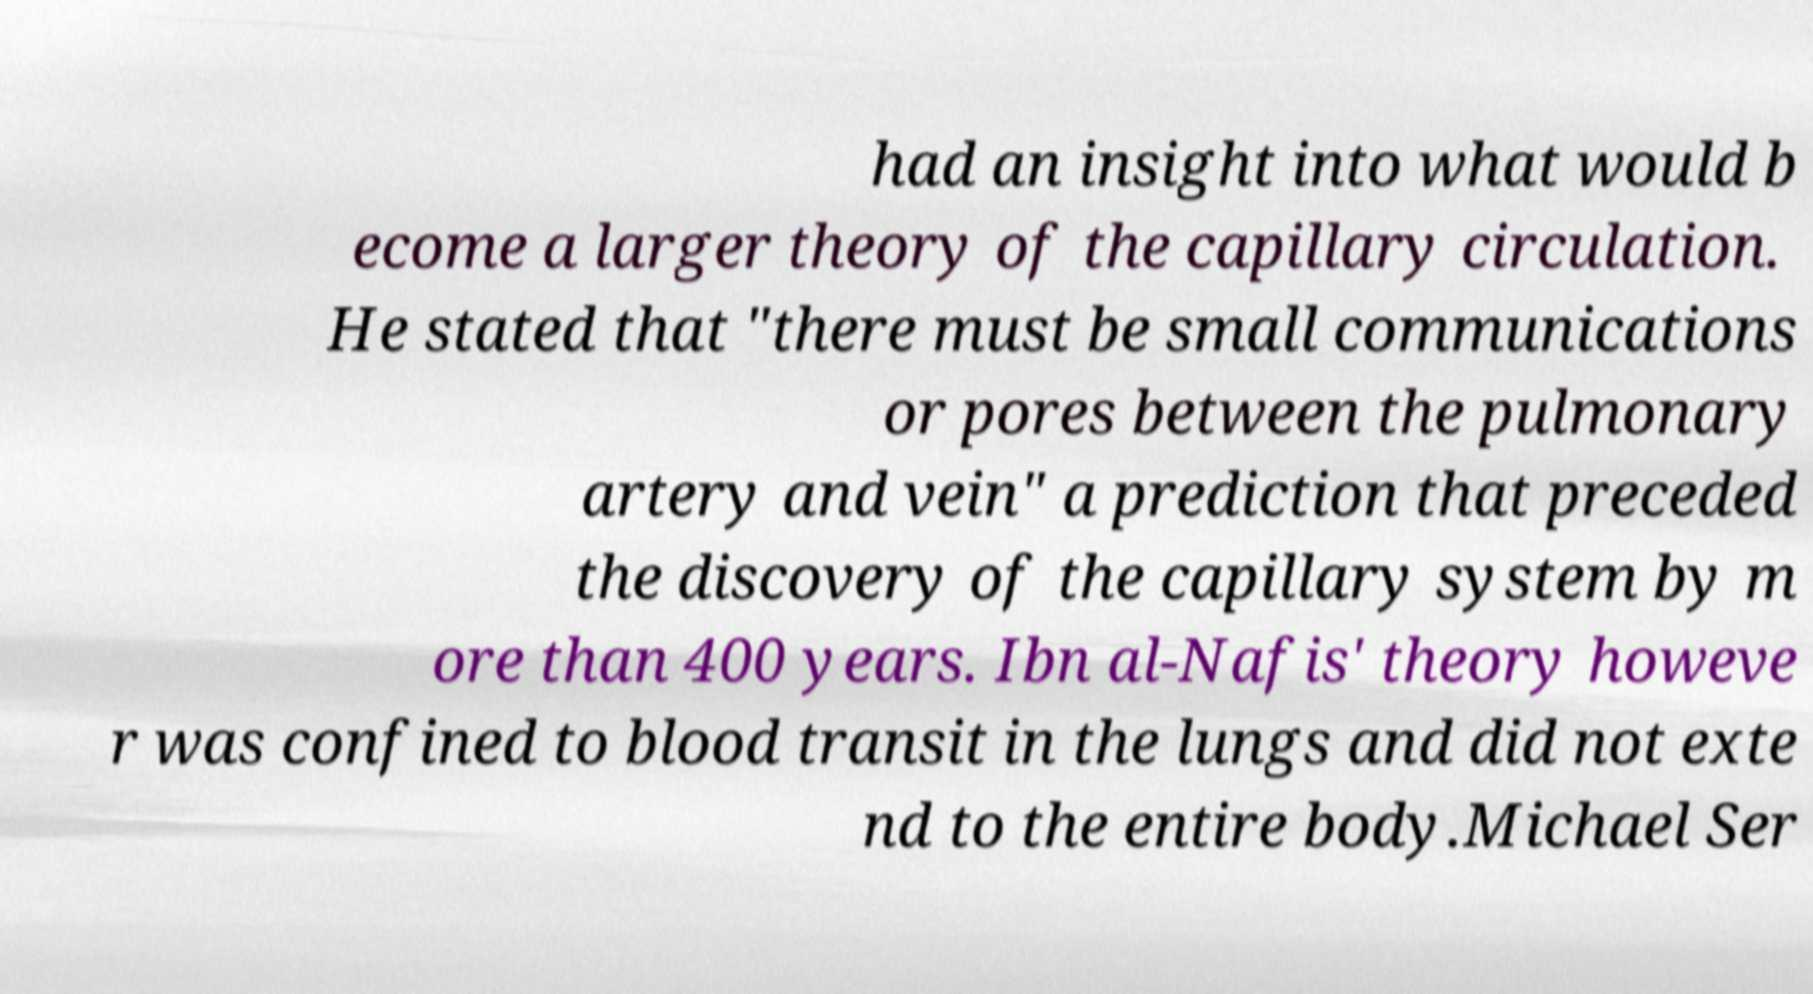I need the written content from this picture converted into text. Can you do that? had an insight into what would b ecome a larger theory of the capillary circulation. He stated that "there must be small communications or pores between the pulmonary artery and vein" a prediction that preceded the discovery of the capillary system by m ore than 400 years. Ibn al-Nafis' theory howeve r was confined to blood transit in the lungs and did not exte nd to the entire body.Michael Ser 